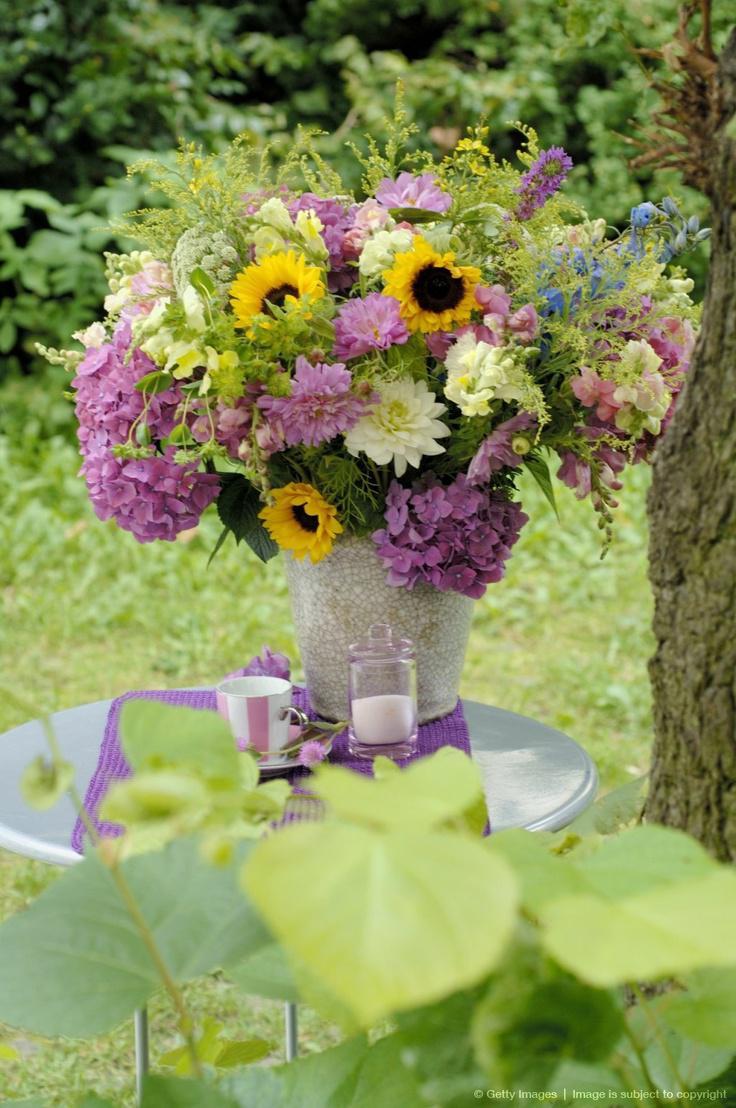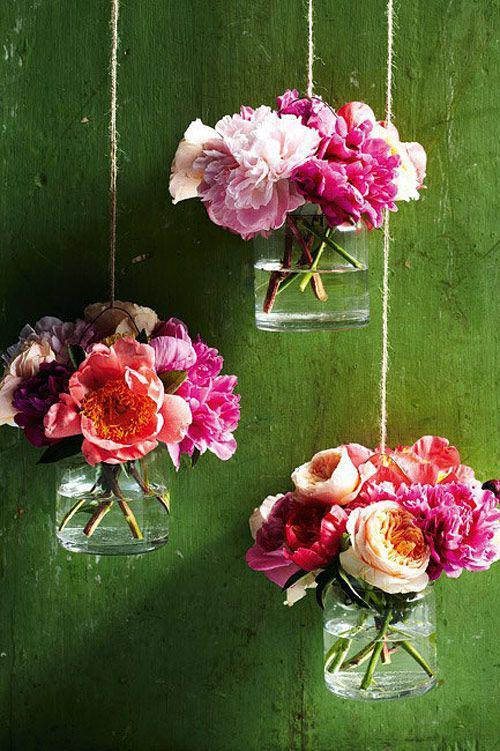The first image is the image on the left, the second image is the image on the right. Given the left and right images, does the statement "At least one vase is hanging." hold true? Answer yes or no. Yes. 